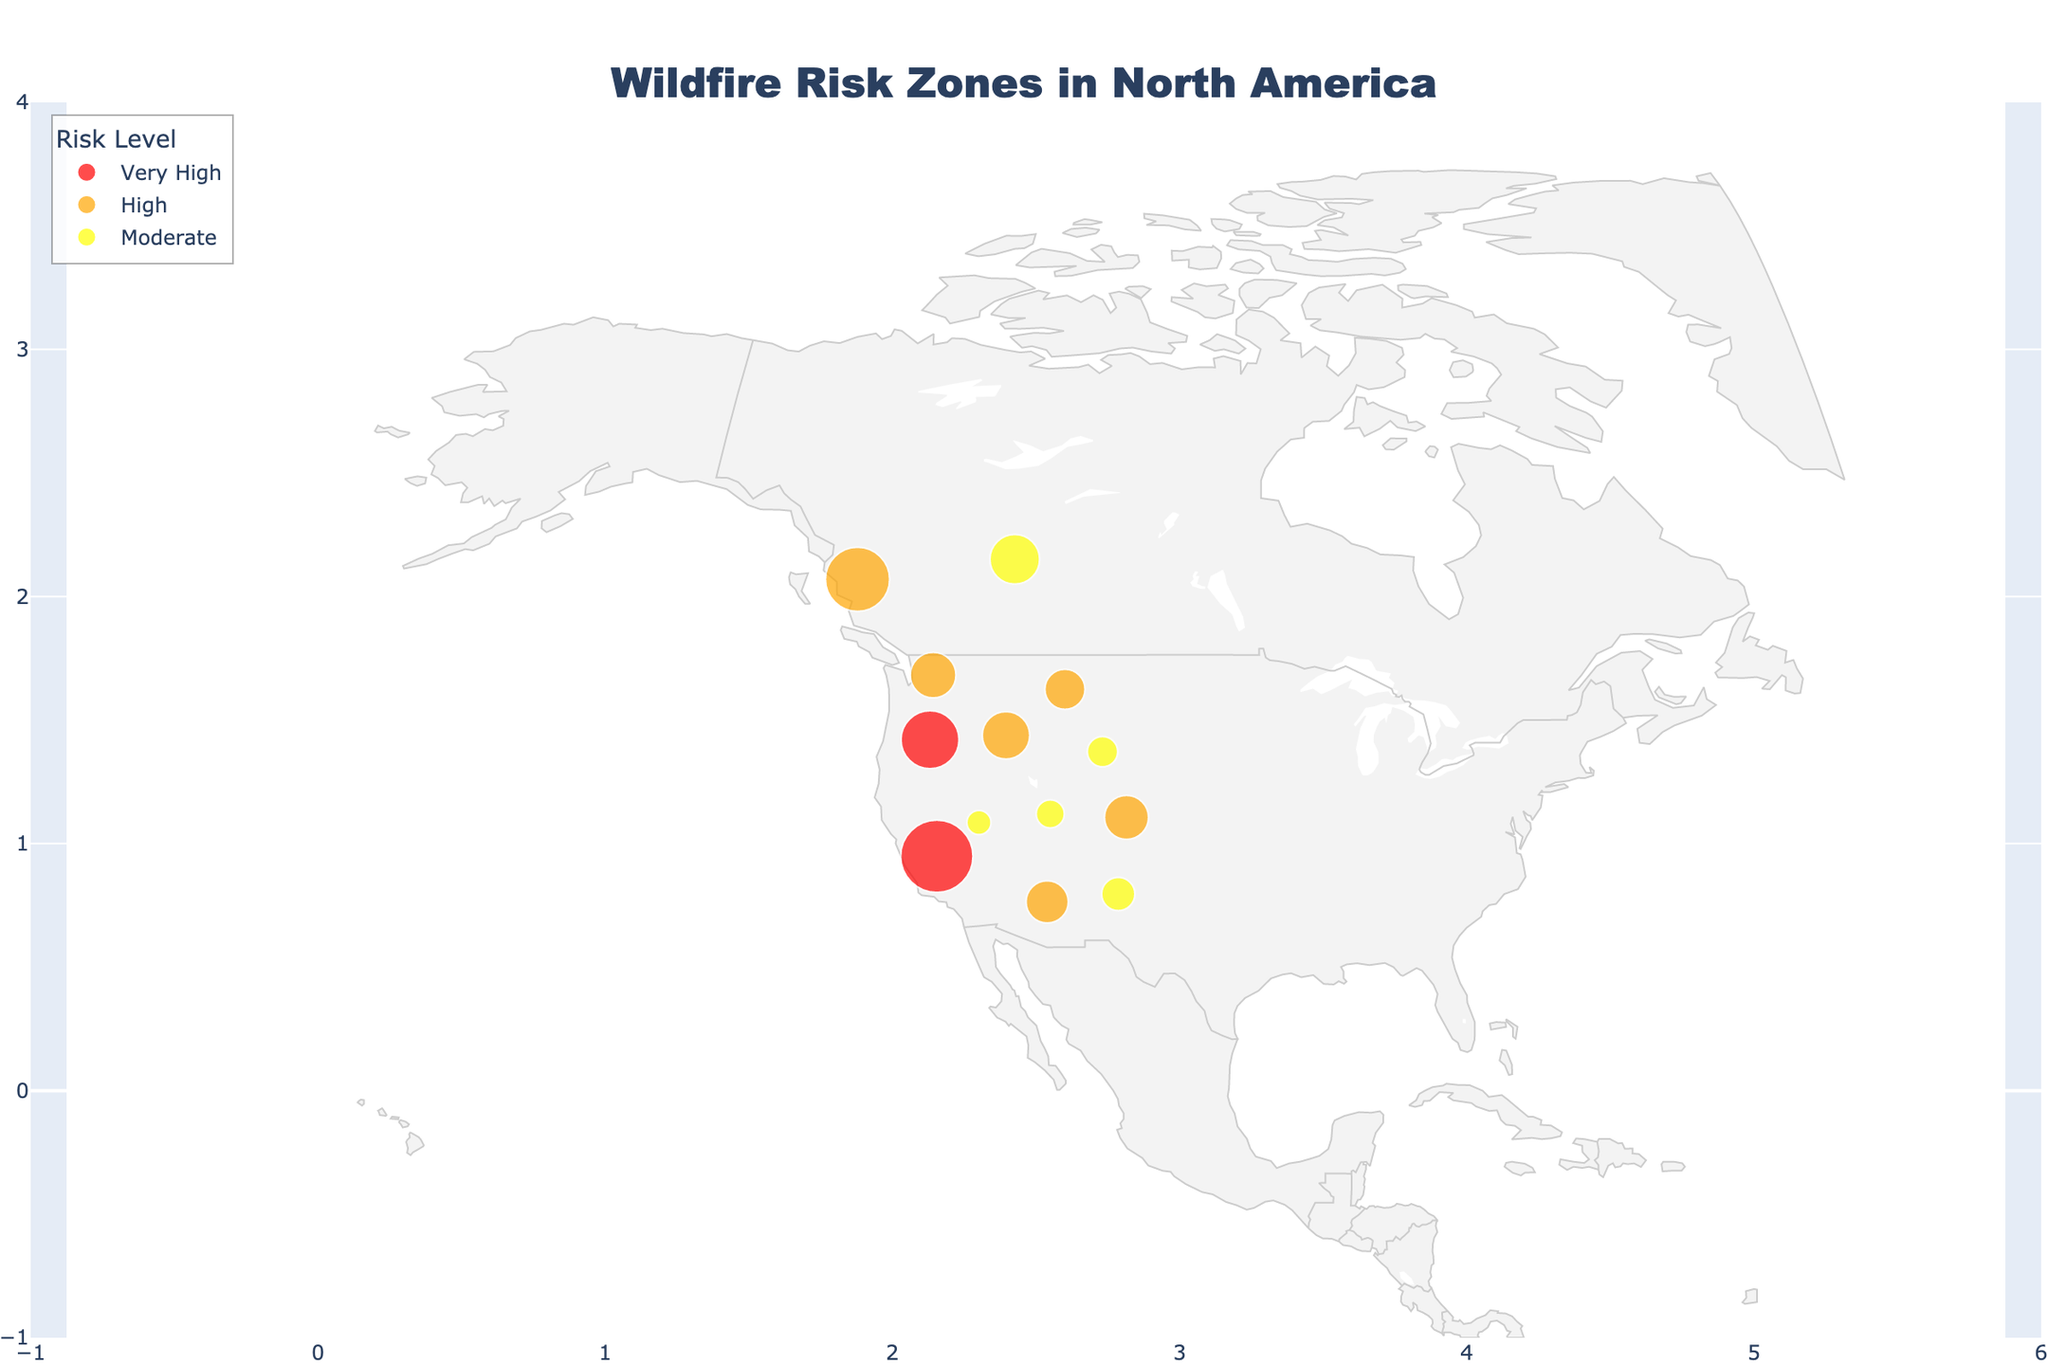What's the title of the map? The title is displayed prominently at the top of the map.
Answer: Wildfire Risk Zones in North America How many regions are marked as having "Very High" wildfire risk? By looking at the color-coded regions corresponding to "Very High" risk color (red), count the number of data points highlighted in this color.
Answer: 2 Which region has the largest fire acreage recorded? Check the hover data for each region and identify the region with the highest value under "Largest Fire Acreage".
Answer: British Columbia What is the color used to represent "Moderate" wildfire risk? Refer to the color legend and find the color assigned to the "Moderate" risk level.
Answer: Yellow Which two regions have the highest historical fire counts, and what are their counts? Locate the two counties with the largest-sized markers, indicating the greatest historical fire counts. California and British Columbia are these regions. Check their respective fire counts.
Answer: California: 8750, British Columbia: 6890 What is the average size of the largest fire acreage among regions classified under "High" wildfire risk? First, list the largest fire acreages for the regions under "High" risk. These regions are Colorado, Arizona, Idaho, Montana, and Washington. Then, calculate the average of these values. (137760 + 538049 + 439352 + 988845 + 273405) / 5 = 475882.2
Answer: 475,882.2 Which region in the United States has the lowest historical fire count among those with "Moderate" wildfire risk? Check the markers with the smallest sizes among the regions classified as "Moderate" risk and located in the United States. Compare the "Historical Fires" count shown in the hover data for these regions.
Answer: Utah How does the wildfire risk in Oregon compare to that in Alberta based on the provided data categories? Oregon is marked with "Very High" risk, whereas Alberta is marked with "Moderate" risk. Additionally, Oregon has 5620 historical fires compared to Alberta's 4120 but has a smaller largest fire acreage of 1031940 compared to Alberta's 589552.
Answer: Oregon has higher risk and historical fires but a smaller largest fire acreage How many regions have more than 5000 historical fires recorded? Count the regions where the hover data shows a "Historical Fires Count" greater than 5000.
Answer: 3 